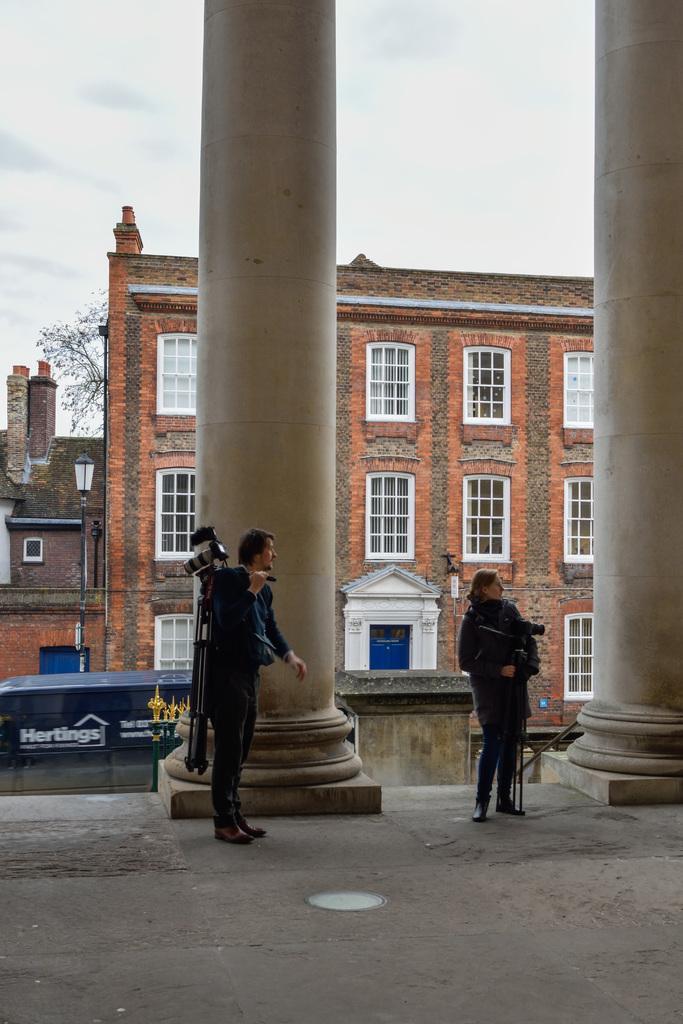Can you describe this image briefly? This picture is clicked outside. In the center we can see the two persons holding some objects and standing on the ground and we can see the pillars and some other objects. In the background we can see the sky, tree, buildings and a lamp attached to the pole and some other objects. 